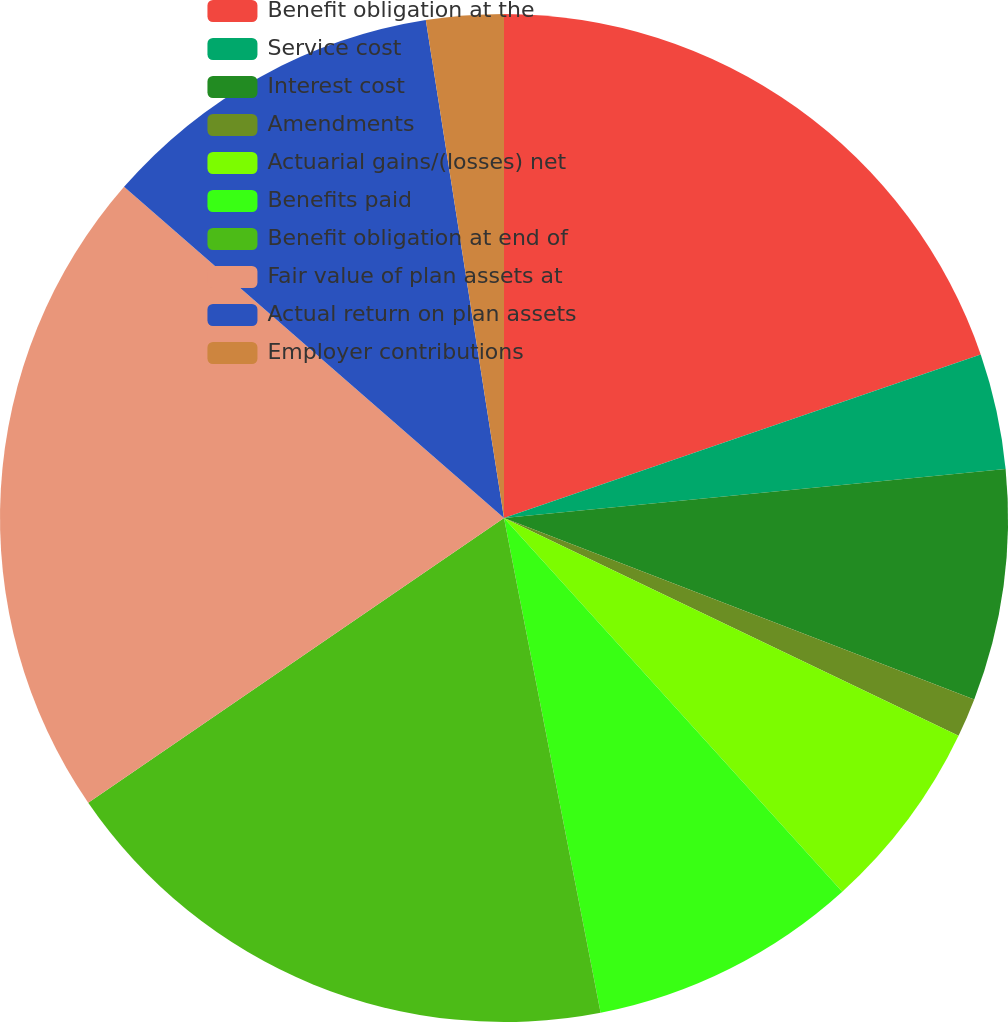Convert chart to OTSL. <chart><loc_0><loc_0><loc_500><loc_500><pie_chart><fcel>Benefit obligation at the<fcel>Service cost<fcel>Interest cost<fcel>Amendments<fcel>Actuarial gains/(losses) net<fcel>Benefits paid<fcel>Benefit obligation at end of<fcel>Fair value of plan assets at<fcel>Actual return on plan assets<fcel>Employer contributions<nl><fcel>19.74%<fcel>3.71%<fcel>7.41%<fcel>1.25%<fcel>6.18%<fcel>8.64%<fcel>18.51%<fcel>20.97%<fcel>11.11%<fcel>2.48%<nl></chart> 